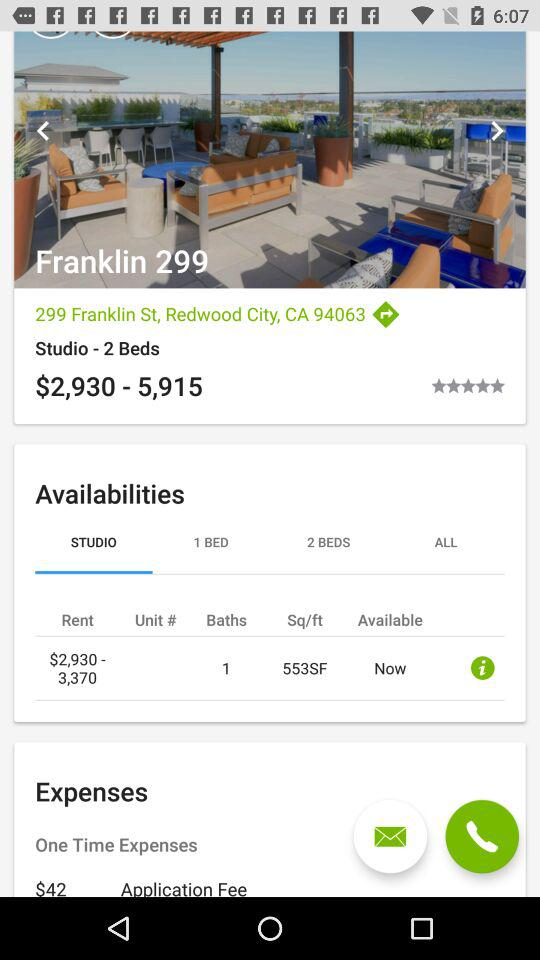What is the area of the studio? The area of the studio is 553 square feet. 